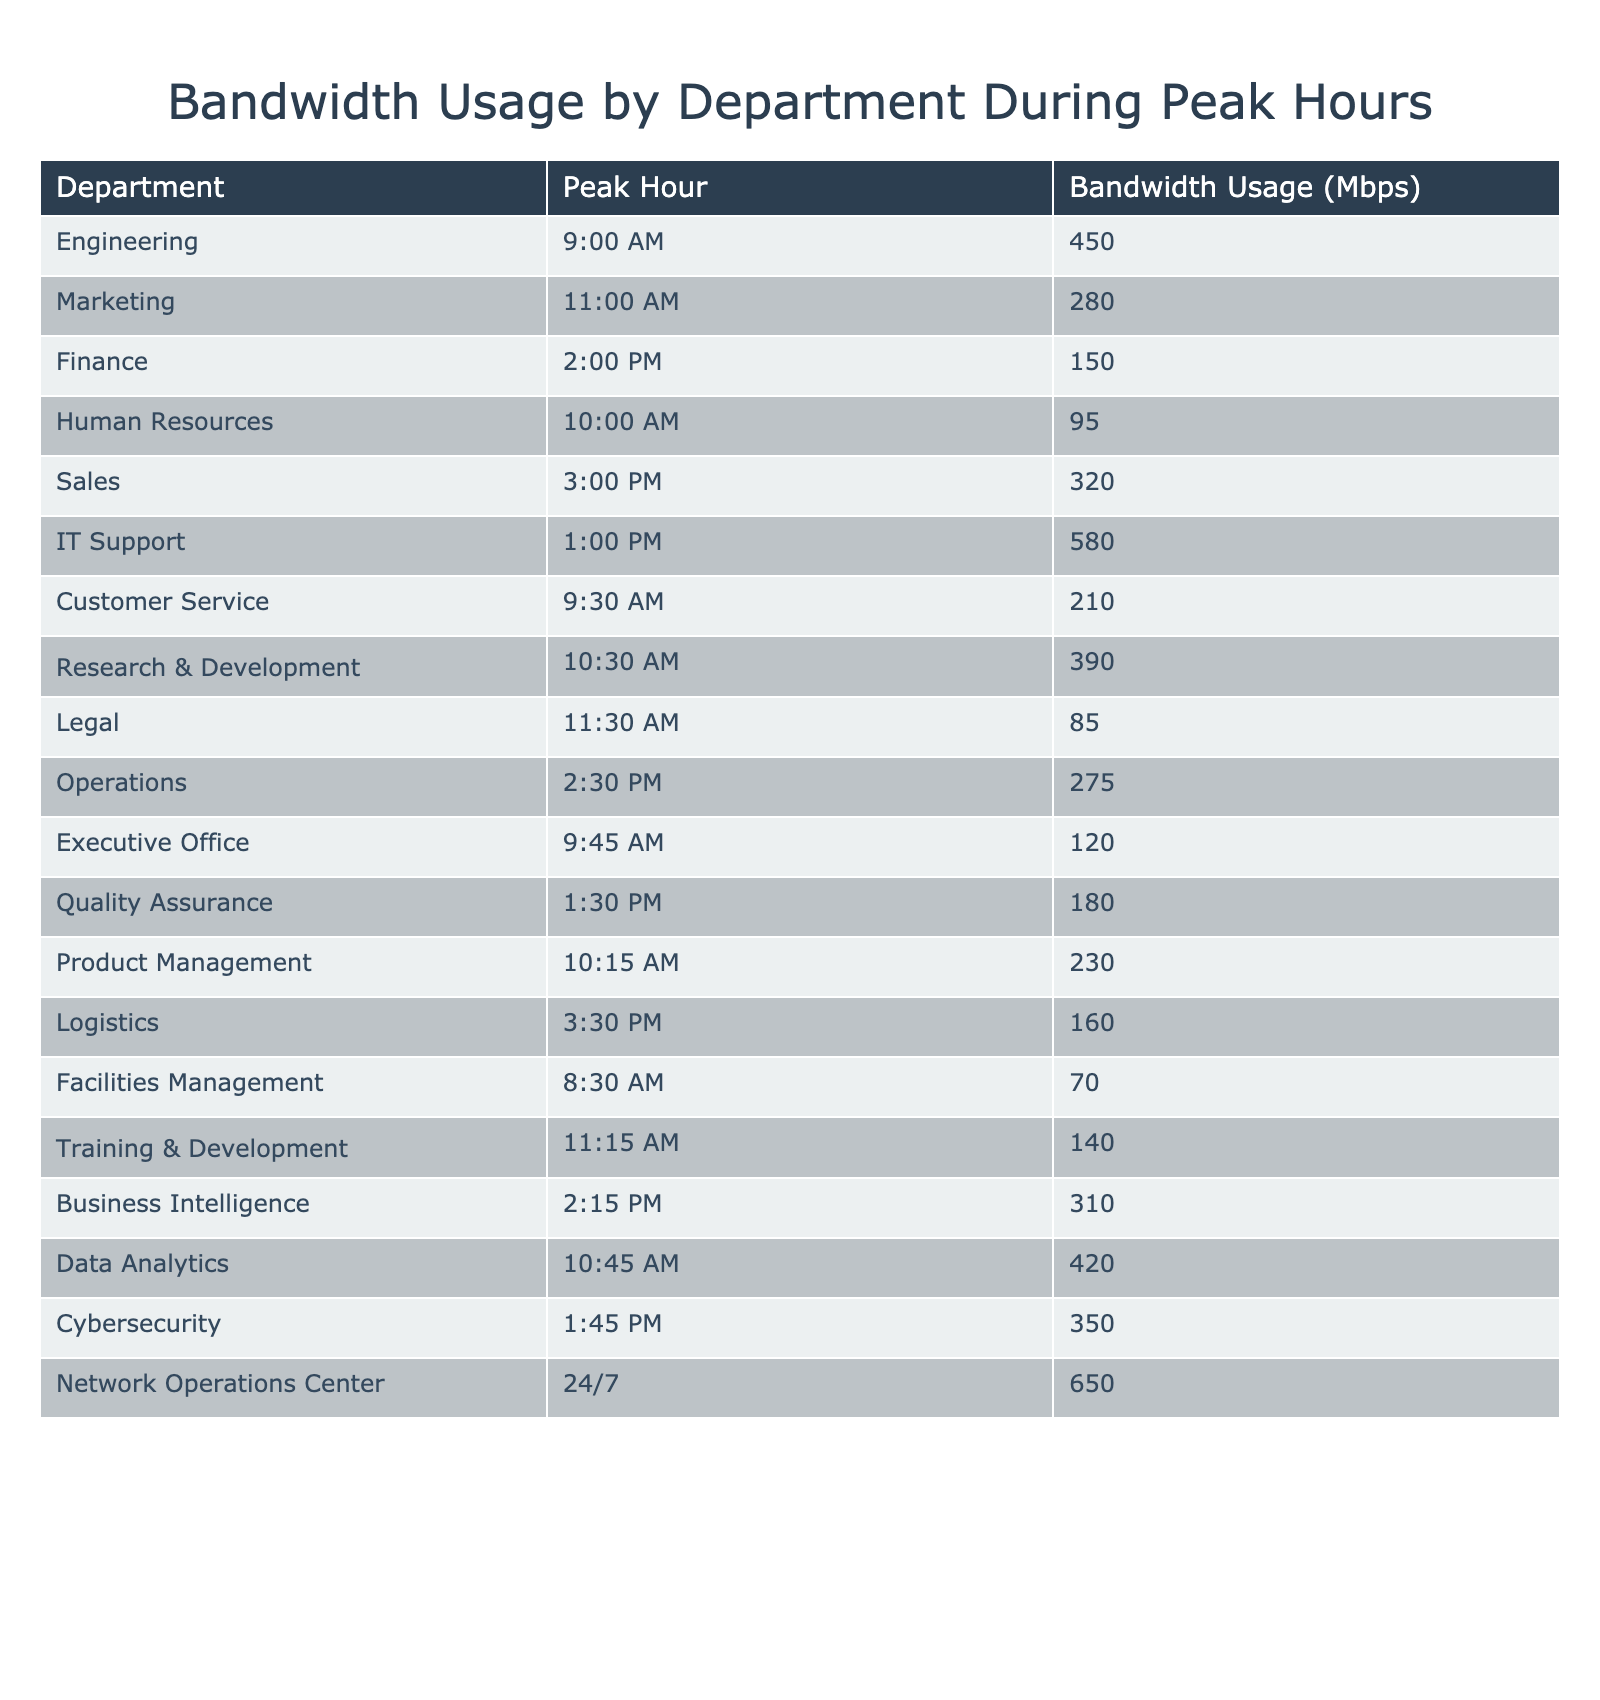What is the highest bandwidth usage recorded among the departments? The table lists the bandwidth usage for each department, and the highest value is 650 Mbps for the Network Operations Center.
Answer: 650 Mbps Which department has the peak hour usage at 1:00 PM? According to the table, IT Support has the peak hour usage at 1:00 PM with a bandwidth usage of 580 Mbps.
Answer: IT Support How many departments have a bandwidth usage greater than 300 Mbps? By reviewing the table, we find that the departments with usage over 300 Mbps are Engineering (450), IT Support (580), Sales (320), Research & Development (390), Data Analytics (420), and Business Intelligence (310). This totals to 6 departments.
Answer: 6 What is the average bandwidth usage of all departments during peak hours? To find the average, we sum all the bandwidth usages (450 + 280 + 150 + 95 + 320 + 580 + 210 + 390 + 85 + 275 + 120 + 180 + 230 + 160 + 70 + 140 + 310 + 420 + 350 + 650) which equals 3,360 Mbps. Dividing by the number of departments (20), we get an average of 168 Mbps.
Answer: 168 Mbps Is there a department that uses less than 100 Mbps during peak hours? The table indicates that Facilities Management has a usage of 70 Mbps, which is indeed less than 100 Mbps.
Answer: Yes What is the difference in bandwidth usage between the IT Support and the Customer Service departments? IT Support uses 580 Mbps and Customer Service uses 210 Mbps. The difference in usage is 580 - 210 = 370 Mbps.
Answer: 370 Mbps Which department has the earliest recorded peak hour? Scanning the table, Facilities Management has its peak hour at 8:30 AM, which is earlier than all other departments listed.
Answer: Facilities Management If we sum the bandwidth usage of the Engineering and Research & Development departments, what do we get? Engineering uses 450 Mbps and Research & Development uses 390 Mbps. Their total bandwidth usage sums to 450 + 390 = 840 Mbps.
Answer: 840 Mbps What proportion of the total bandwidth used during peak hours does the Network Operations Center account for? Total bandwidth usage is 3,360 Mbps and the Network Operations Center uses 650 Mbps. The proportion is calculated as (650 / 3360) * 100, which equals approximately 19.4%.
Answer: 19.4% Which department had a bandwidth usage closest to 200 Mbps? By examining the table, Customer Service had 210 Mbps, which is the closest to 200 Mbps compared to other departments.
Answer: Customer Service 